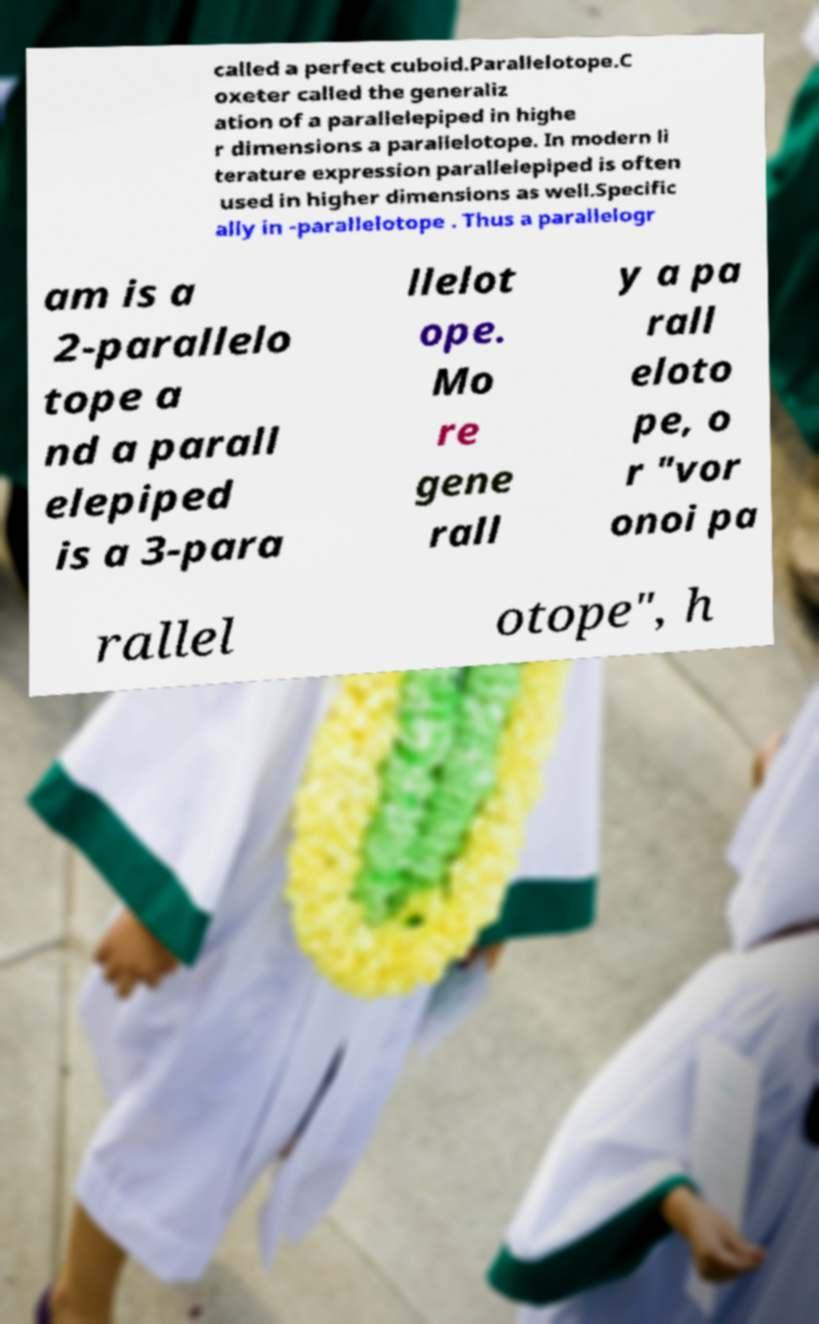Please read and relay the text visible in this image. What does it say? called a perfect cuboid.Parallelotope.C oxeter called the generaliz ation of a parallelepiped in highe r dimensions a parallelotope. In modern li terature expression parallelepiped is often used in higher dimensions as well.Specific ally in -parallelotope . Thus a parallelogr am is a 2-parallelo tope a nd a parall elepiped is a 3-para llelot ope. Mo re gene rall y a pa rall eloto pe, o r "vor onoi pa rallel otope", h 